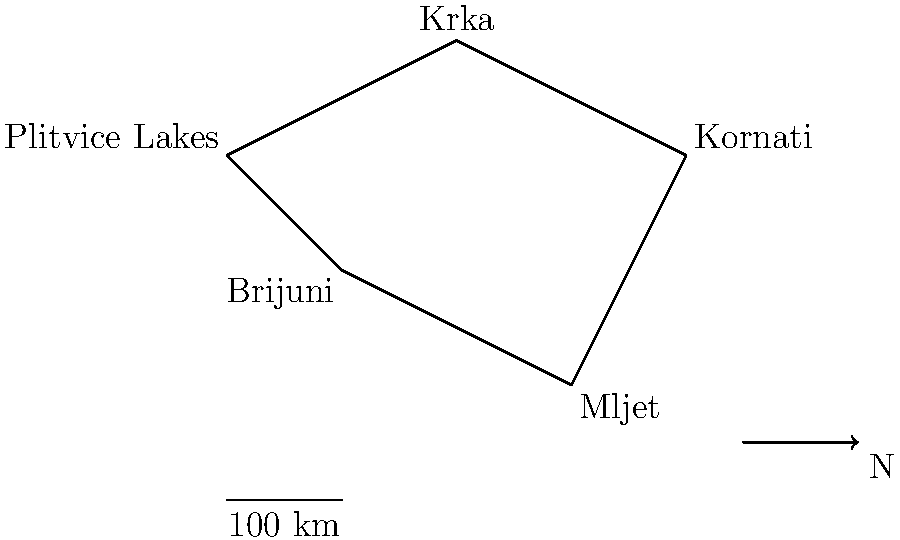You're planning a tour of Croatian national parks, starting from Plitvice Lakes and visiting each park exactly once before returning to the starting point. If you travel clockwise and the total distance is 1000 km, what's the average distance between each park? To solve this problem, let's break it down into steps:

1. Identify the route:
   The clockwise route from Plitvice Lakes is: Plitvice Lakes → Krka → Kornati → Mljet → Brijuni → Plitvice Lakes

2. Count the number of segments:
   There are 5 segments in total (connecting 5 parks and returning to the start)

3. Calculate the average distance:
   Total distance = 1000 km
   Number of segments = 5
   Average distance = Total distance ÷ Number of segments
   $$ \text{Average distance} = \frac{1000 \text{ km}}{5} = 200 \text{ km} $$

Therefore, the average distance between each park is 200 km.
Answer: 200 km 